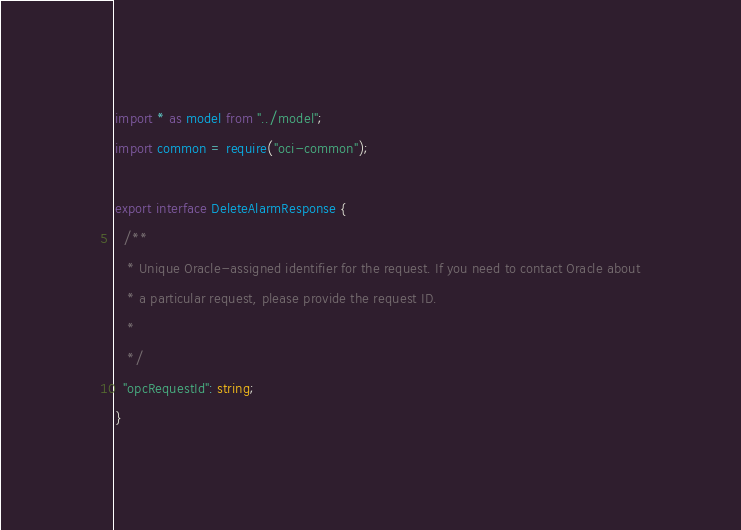<code> <loc_0><loc_0><loc_500><loc_500><_TypeScript_>
import * as model from "../model";
import common = require("oci-common");

export interface DeleteAlarmResponse {
  /**
   * Unique Oracle-assigned identifier for the request. If you need to contact Oracle about
   * a particular request, please provide the request ID.
   *
   */
  "opcRequestId": string;
}
</code> 